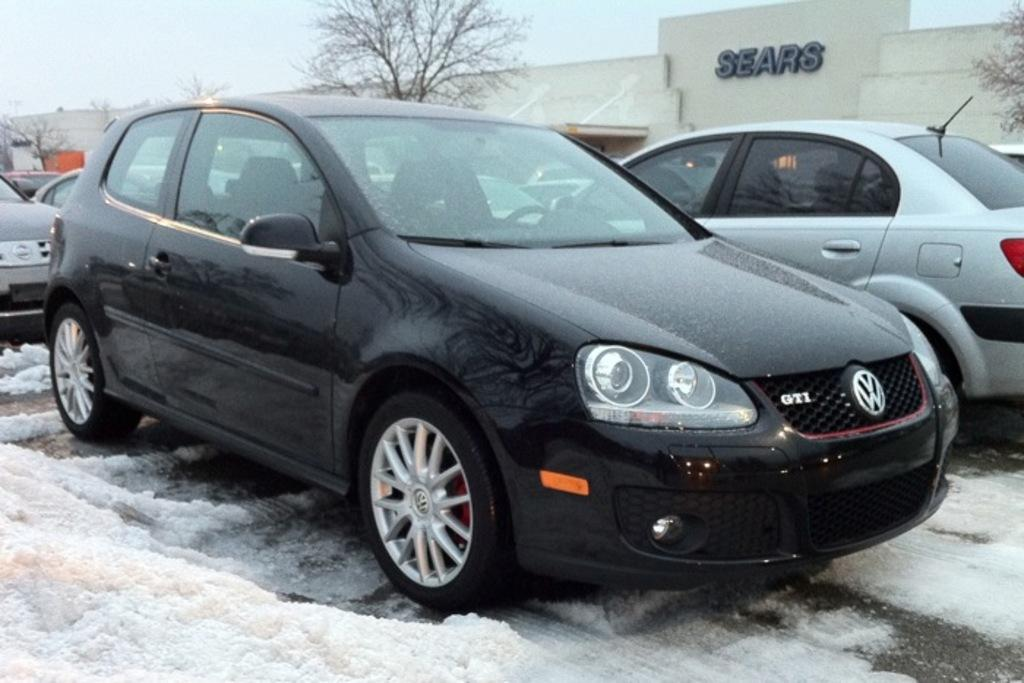What types of objects can be seen in the image? There are vehicles, trees, and buildings in the image. What is the condition of the ground in the image? The ground appears to be covered in snow. Can you describe any text visible in the image? There is text visible on one of the buildings. What can be seen in the background of the image? The sky is visible in the background of the image. How many chairs are visible in the image? There are no chairs present in the image. What type of collar is being worn by the tree in the image? There is no collar present on the tree in the image; it is a natural object. 